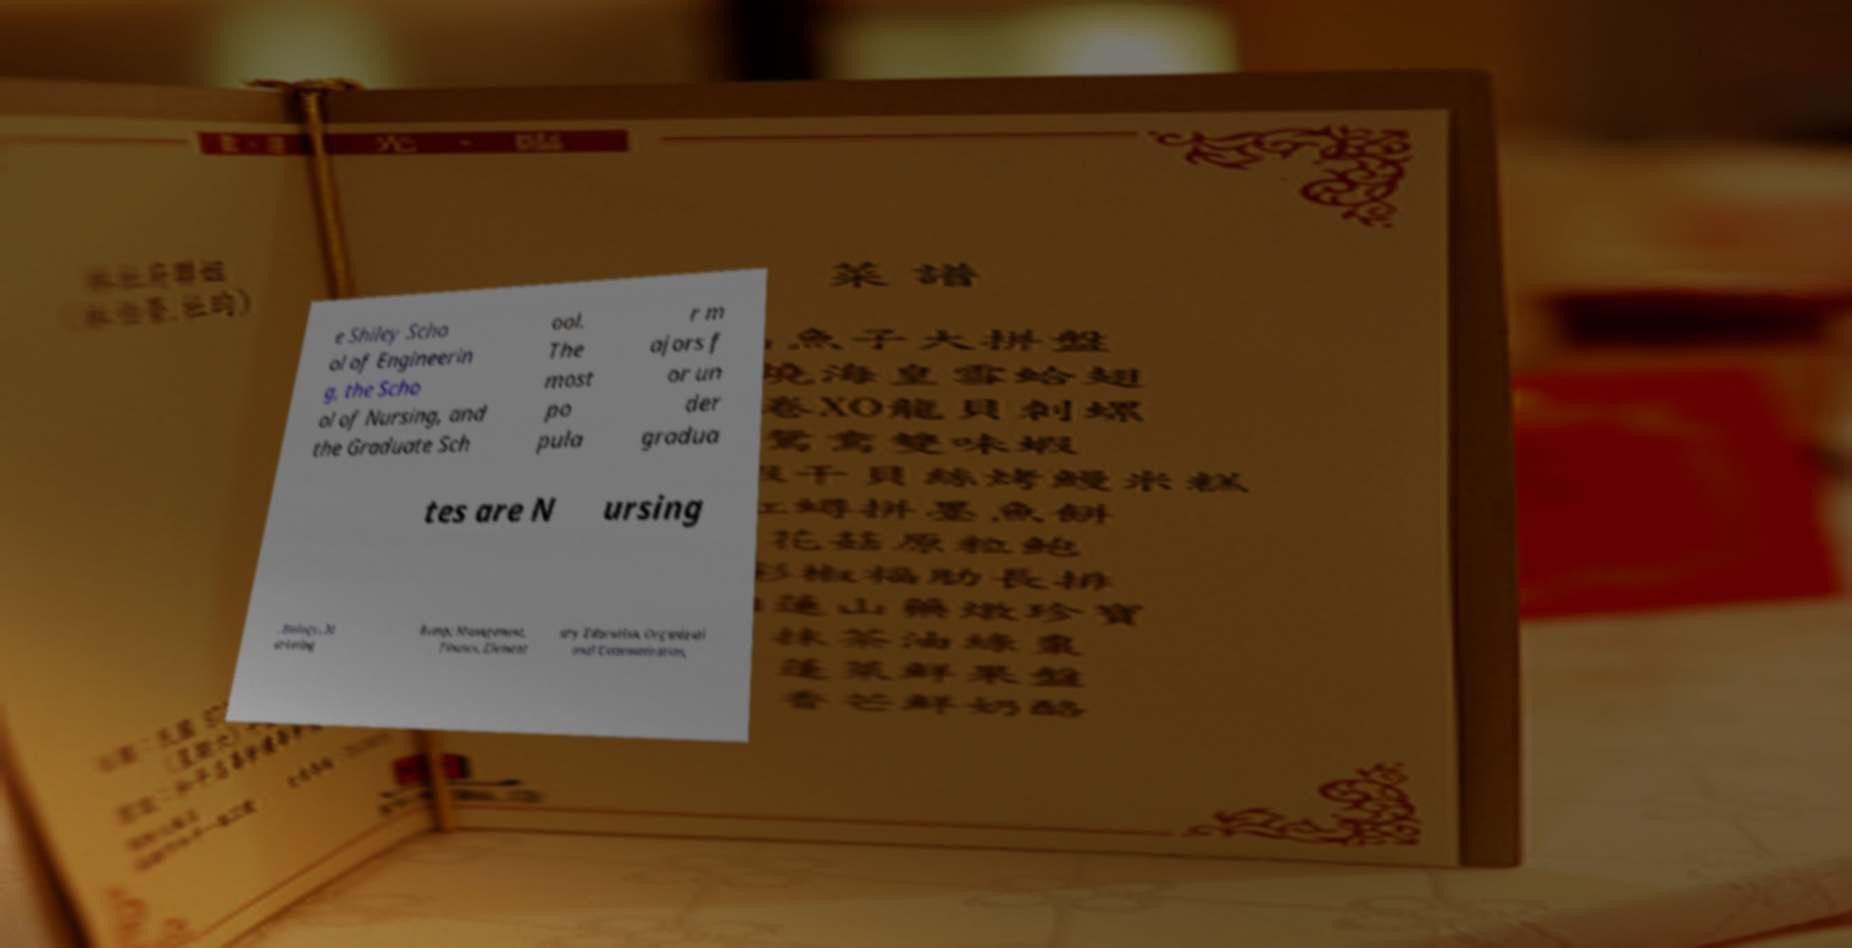Please identify and transcribe the text found in this image. e Shiley Scho ol of Engineerin g, the Scho ol of Nursing, and the Graduate Sch ool. The most po pula r m ajors f or un der gradua tes are N ursing , Biology, M arketing &amp; Management, Finance, Element ary Education, Organizati onal Communication, 